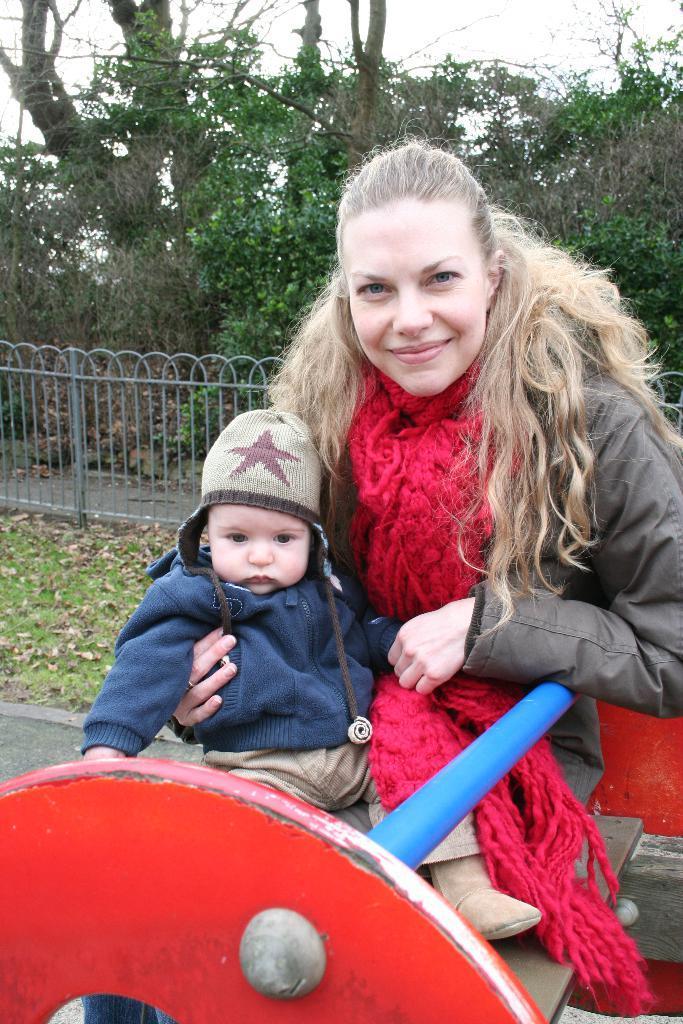Could you give a brief overview of what you see in this image? In this image I can see a person and the child with different color dresses. These people are sitting on the red, blue and brown color object. In the background I can see the railing, trees and the sky. 